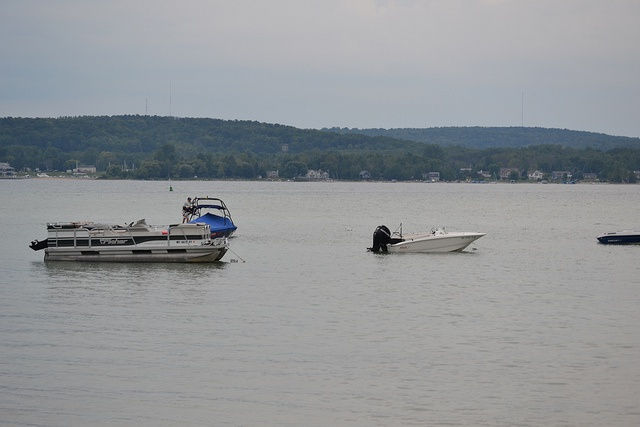Describe the objects in this image and their specific colors. I can see boat in darkgray, gray, and black tones, boat in darkgray, gray, and black tones, boat in darkgray, black, blue, and navy tones, boat in darkgray, black, and gray tones, and people in darkgray, gray, black, and maroon tones in this image. 